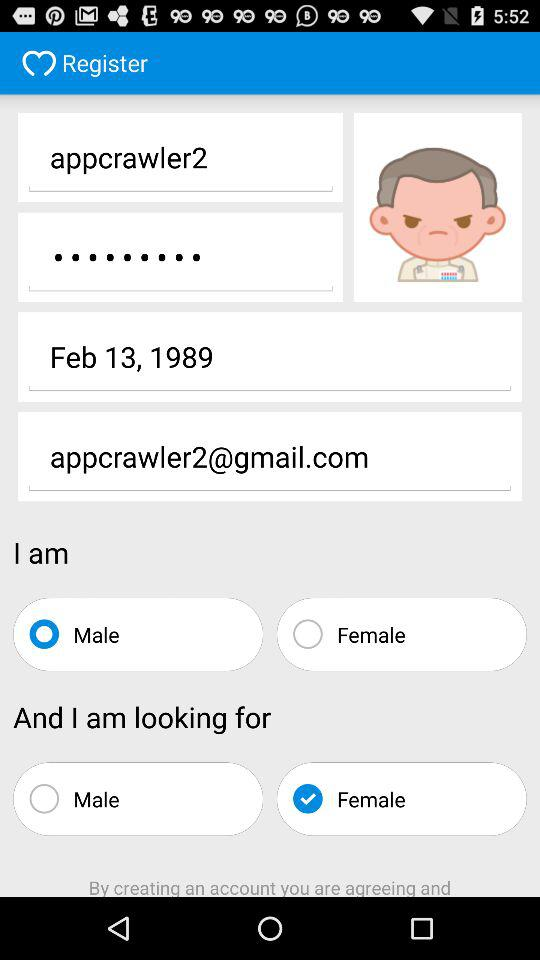Which option is selected in gender? The selected gender is male. 